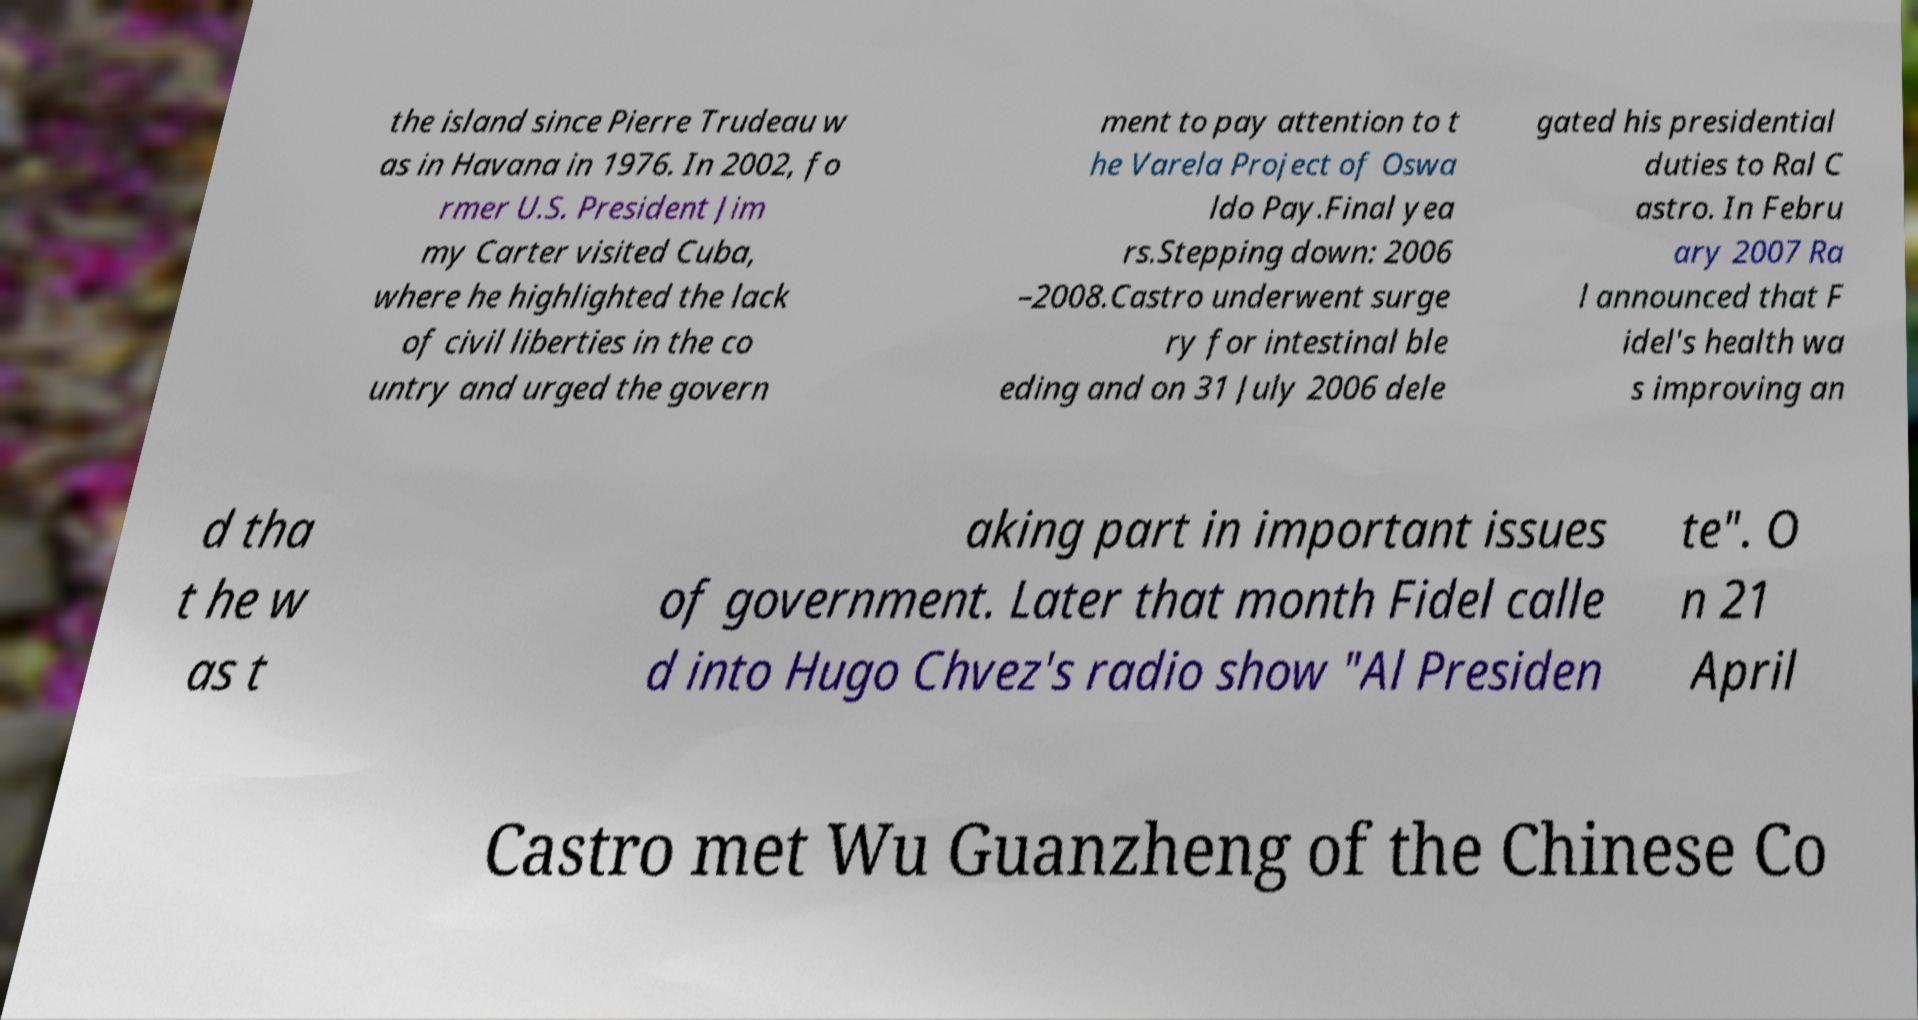Please read and relay the text visible in this image. What does it say? the island since Pierre Trudeau w as in Havana in 1976. In 2002, fo rmer U.S. President Jim my Carter visited Cuba, where he highlighted the lack of civil liberties in the co untry and urged the govern ment to pay attention to t he Varela Project of Oswa ldo Pay.Final yea rs.Stepping down: 2006 –2008.Castro underwent surge ry for intestinal ble eding and on 31 July 2006 dele gated his presidential duties to Ral C astro. In Febru ary 2007 Ra l announced that F idel's health wa s improving an d tha t he w as t aking part in important issues of government. Later that month Fidel calle d into Hugo Chvez's radio show "Al Presiden te". O n 21 April Castro met Wu Guanzheng of the Chinese Co 